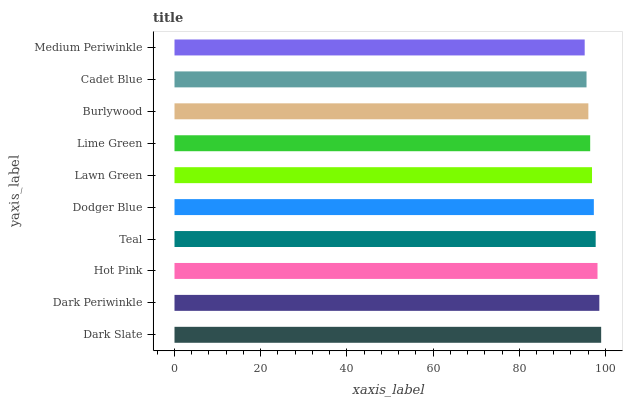Is Medium Periwinkle the minimum?
Answer yes or no. Yes. Is Dark Slate the maximum?
Answer yes or no. Yes. Is Dark Periwinkle the minimum?
Answer yes or no. No. Is Dark Periwinkle the maximum?
Answer yes or no. No. Is Dark Slate greater than Dark Periwinkle?
Answer yes or no. Yes. Is Dark Periwinkle less than Dark Slate?
Answer yes or no. Yes. Is Dark Periwinkle greater than Dark Slate?
Answer yes or no. No. Is Dark Slate less than Dark Periwinkle?
Answer yes or no. No. Is Dodger Blue the high median?
Answer yes or no. Yes. Is Lawn Green the low median?
Answer yes or no. Yes. Is Lawn Green the high median?
Answer yes or no. No. Is Burlywood the low median?
Answer yes or no. No. 